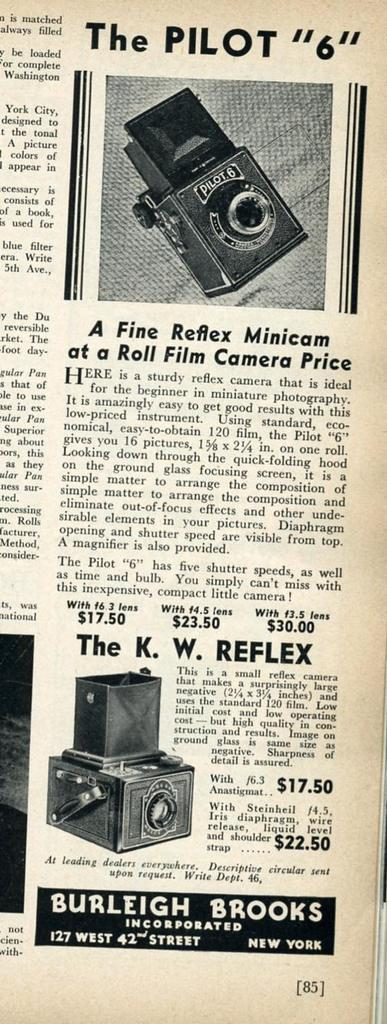What is the main object in the picture? There is a newspaper in the picture. What can be found within the newspaper? The newspaper contains pictures of objects and text. What is the color scheme of the picture? The picture is black and white in color. How many cups are visible on the van in the sand in the image? There is no van, cups, or sand present in the image; it only features a black and white newspaper. 